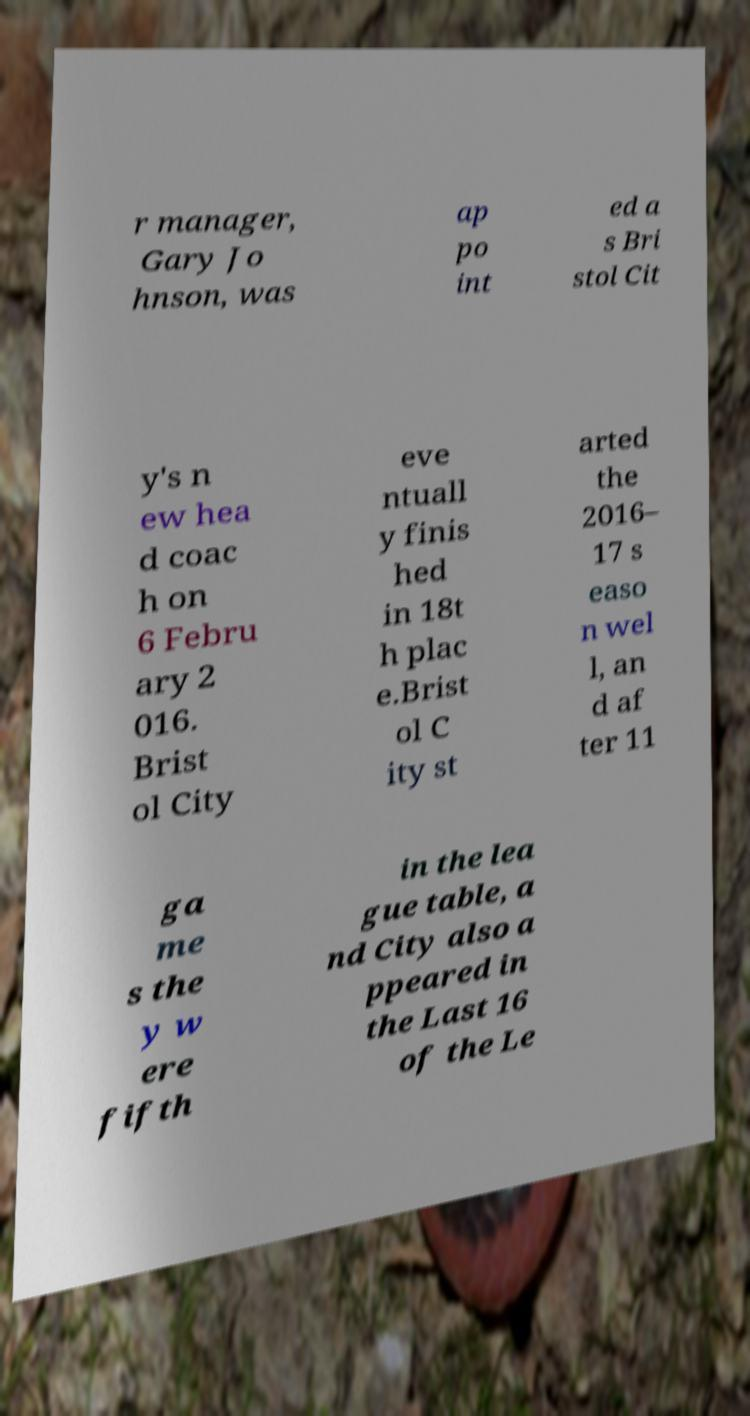Could you extract and type out the text from this image? r manager, Gary Jo hnson, was ap po int ed a s Bri stol Cit y's n ew hea d coac h on 6 Febru ary 2 016. Brist ol City eve ntuall y finis hed in 18t h plac e.Brist ol C ity st arted the 2016– 17 s easo n wel l, an d af ter 11 ga me s the y w ere fifth in the lea gue table, a nd City also a ppeared in the Last 16 of the Le 